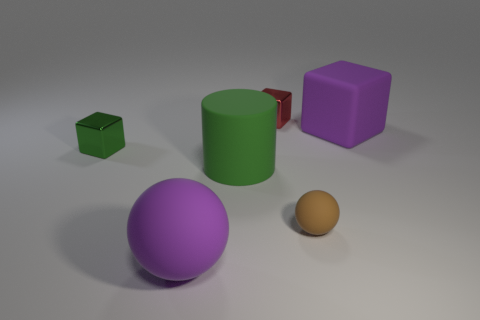Add 1 large green rubber objects. How many objects exist? 7 Subtract all balls. How many objects are left? 4 Add 1 blue things. How many blue things exist? 1 Subtract 0 yellow cubes. How many objects are left? 6 Subtract all small gray balls. Subtract all large green cylinders. How many objects are left? 5 Add 5 tiny green things. How many tiny green things are left? 6 